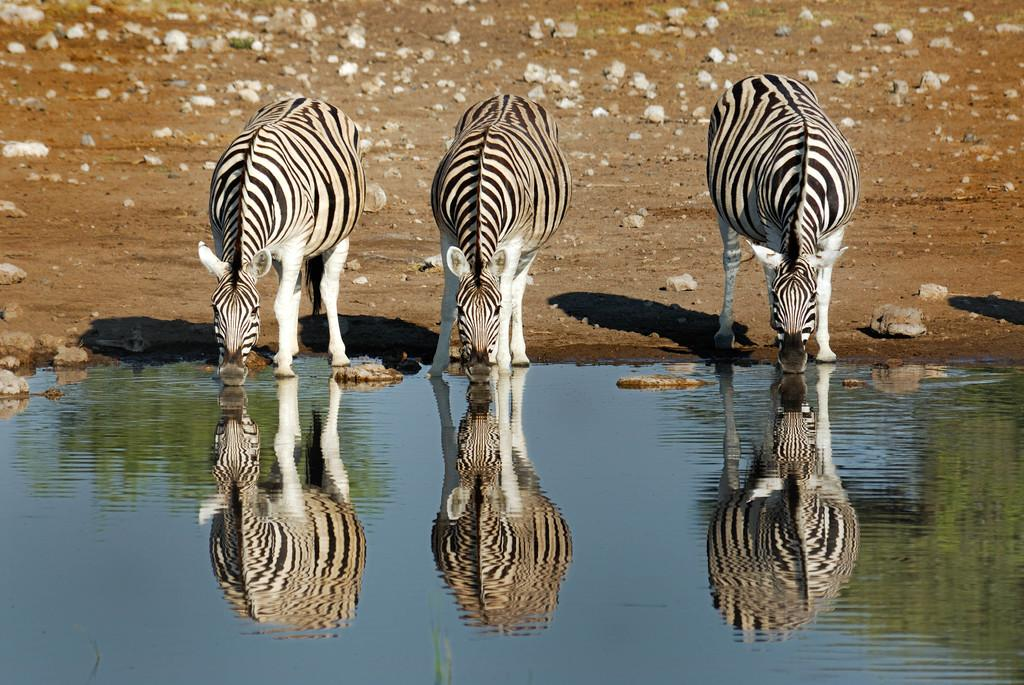What animals are present in the image? There are zebras in the image. Where are the zebras located in relation to the water? The zebras are standing in front of the water. What can be seen in the background of the image? There are rocks in the background of the image. What color is the robin's sweater in the image? There is no robin or sweater present in the image; it features zebras standing in front of the water with rocks in the background. 